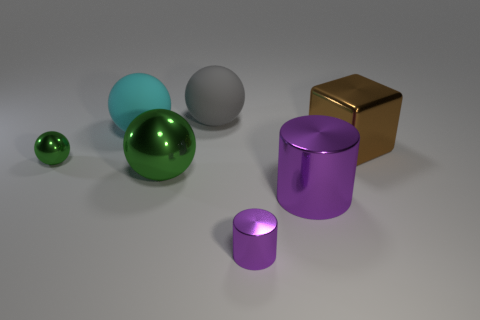Subtract all gray matte spheres. How many spheres are left? 3 Add 3 brown rubber blocks. How many objects exist? 10 Subtract all blocks. How many objects are left? 6 Subtract all cyan cylinders. How many green balls are left? 2 Subtract all green spheres. How many spheres are left? 2 Subtract 1 cylinders. How many cylinders are left? 1 Subtract all cyan cubes. Subtract all cyan spheres. How many cubes are left? 1 Subtract all tiny green spheres. Subtract all tiny green objects. How many objects are left? 5 Add 6 small shiny spheres. How many small shiny spheres are left? 7 Add 7 large cylinders. How many large cylinders exist? 8 